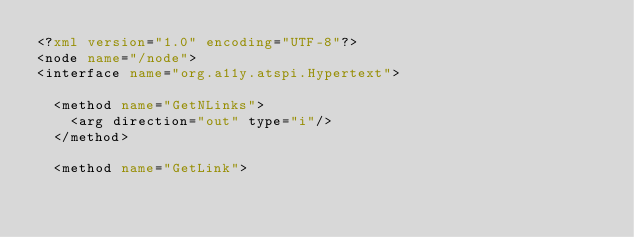Convert code to text. <code><loc_0><loc_0><loc_500><loc_500><_XML_><?xml version="1.0" encoding="UTF-8"?>
<node name="/node">
<interface name="org.a11y.atspi.Hypertext">

  <method name="GetNLinks">
    <arg direction="out" type="i"/>
  </method>

  <method name="GetLink"></code> 